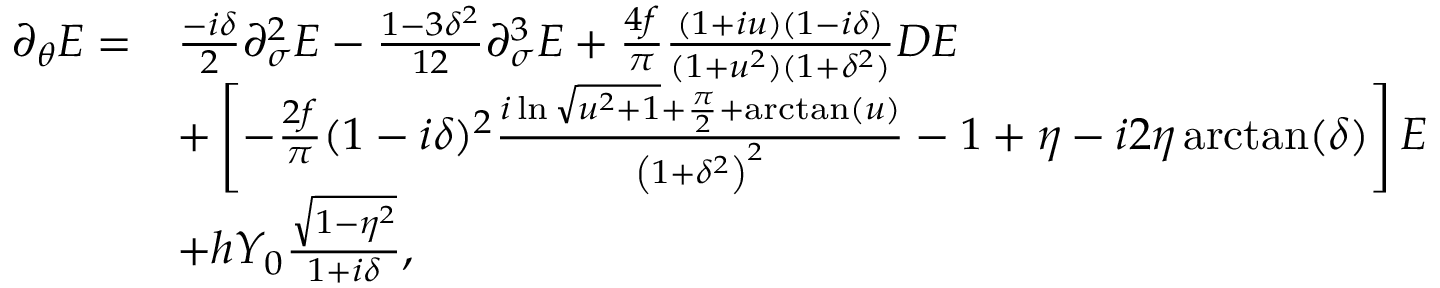Convert formula to latex. <formula><loc_0><loc_0><loc_500><loc_500>\begin{array} { r l } { \partial _ { \theta } E = } & { \frac { - i \delta } { 2 } \partial _ { \sigma } ^ { 2 } E - \frac { 1 - 3 \delta ^ { 2 } } { 1 2 } \partial _ { \sigma } ^ { 3 } E + \frac { 4 f } { \pi } \frac { ( 1 + i u ) ( 1 - i \delta ) } { ( 1 + u ^ { 2 } ) ( 1 + \delta ^ { 2 } ) } D E } \\ & { + \left [ - \frac { 2 f } { \pi } ( 1 - i \delta ) ^ { 2 } \frac { i \ln \sqrt { u ^ { 2 } + 1 } + \frac { \pi } { 2 } + \arctan ( u ) } { \left ( 1 + \delta ^ { 2 } \right ) ^ { 2 } } - 1 + \eta - i 2 \eta \arctan ( \delta ) \right ] E } \\ & { + h Y _ { 0 } \frac { \sqrt { 1 - \eta ^ { 2 } } } { 1 + i \delta } , } \end{array}</formula> 